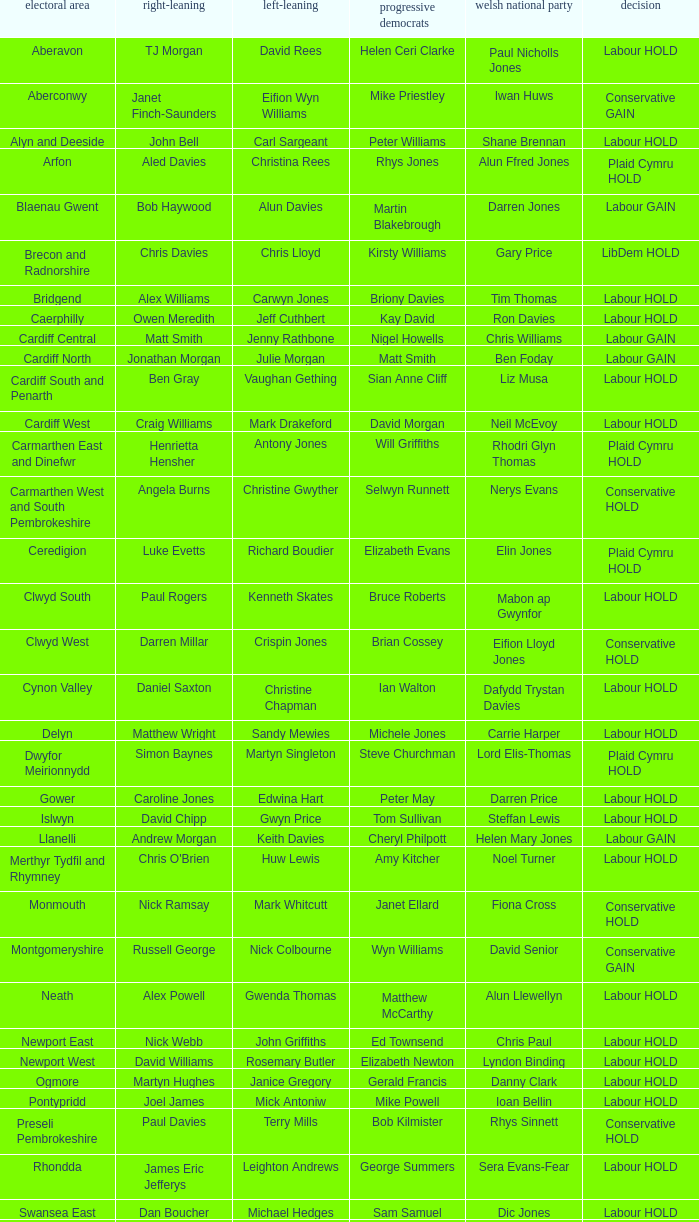In what constituency was the result labour hold and Liberal democrat Elizabeth Newton won? Newport West. 